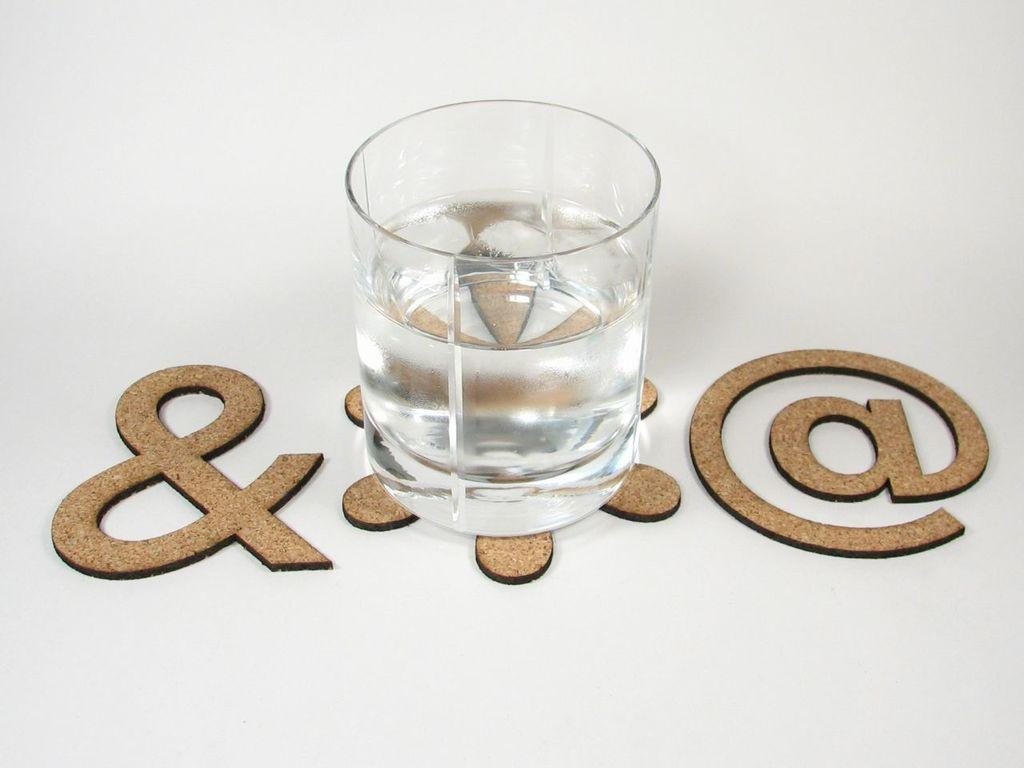What is contained in the glass that is visible in the image? There is a glass of water in the image. What else can be seen in the image besides the glass of water? There are symbols in the image. What is the color of the background in the image? The background of the image is white. How does the person in the image get a haircut while sitting on the glass of water? There is no person in the image, and the glass of water is not being used for a haircut. 